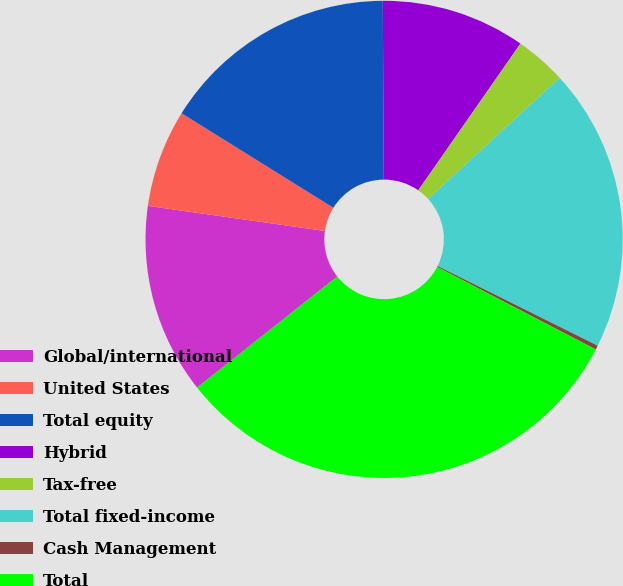Convert chart to OTSL. <chart><loc_0><loc_0><loc_500><loc_500><pie_chart><fcel>Global/international<fcel>United States<fcel>Total equity<fcel>Hybrid<fcel>Tax-free<fcel>Total fixed-income<fcel>Cash Management<fcel>Total<nl><fcel>12.91%<fcel>6.62%<fcel>16.05%<fcel>9.77%<fcel>3.48%<fcel>19.19%<fcel>0.28%<fcel>31.7%<nl></chart> 